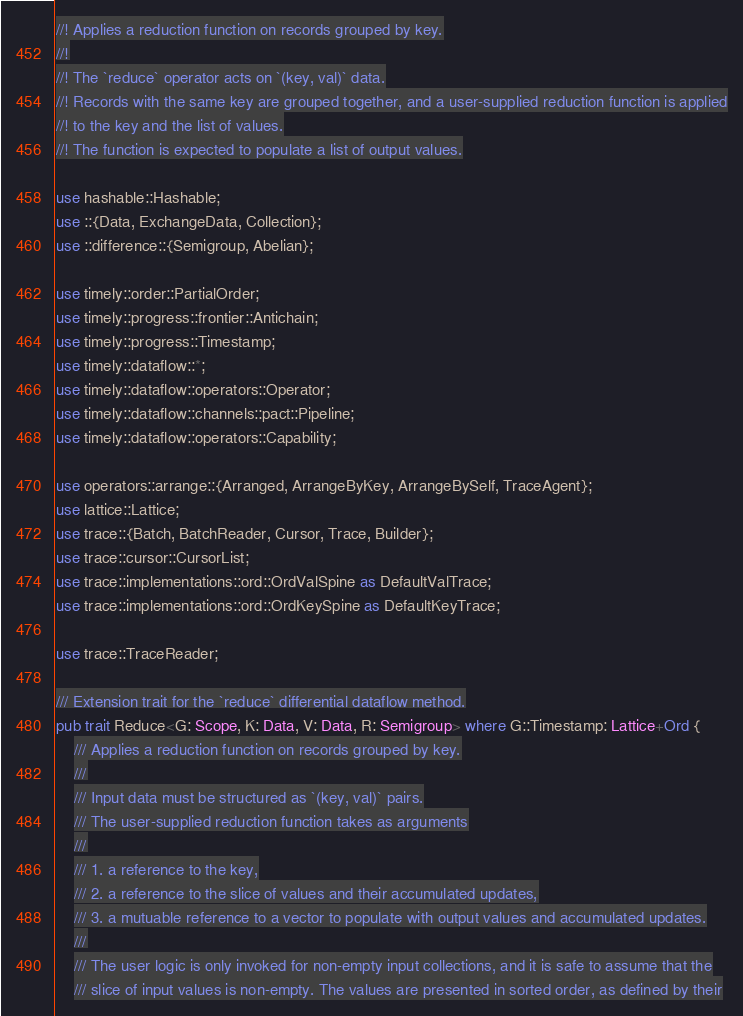<code> <loc_0><loc_0><loc_500><loc_500><_Rust_>//! Applies a reduction function on records grouped by key.
//!
//! The `reduce` operator acts on `(key, val)` data.
//! Records with the same key are grouped together, and a user-supplied reduction function is applied
//! to the key and the list of values.
//! The function is expected to populate a list of output values.

use hashable::Hashable;
use ::{Data, ExchangeData, Collection};
use ::difference::{Semigroup, Abelian};

use timely::order::PartialOrder;
use timely::progress::frontier::Antichain;
use timely::progress::Timestamp;
use timely::dataflow::*;
use timely::dataflow::operators::Operator;
use timely::dataflow::channels::pact::Pipeline;
use timely::dataflow::operators::Capability;

use operators::arrange::{Arranged, ArrangeByKey, ArrangeBySelf, TraceAgent};
use lattice::Lattice;
use trace::{Batch, BatchReader, Cursor, Trace, Builder};
use trace::cursor::CursorList;
use trace::implementations::ord::OrdValSpine as DefaultValTrace;
use trace::implementations::ord::OrdKeySpine as DefaultKeyTrace;

use trace::TraceReader;

/// Extension trait for the `reduce` differential dataflow method.
pub trait Reduce<G: Scope, K: Data, V: Data, R: Semigroup> where G::Timestamp: Lattice+Ord {
    /// Applies a reduction function on records grouped by key.
    ///
    /// Input data must be structured as `(key, val)` pairs.
    /// The user-supplied reduction function takes as arguments
    ///
    /// 1. a reference to the key,
    /// 2. a reference to the slice of values and their accumulated updates,
    /// 3. a mutuable reference to a vector to populate with output values and accumulated updates.
    ///
    /// The user logic is only invoked for non-empty input collections, and it is safe to assume that the
    /// slice of input values is non-empty. The values are presented in sorted order, as defined by their</code> 